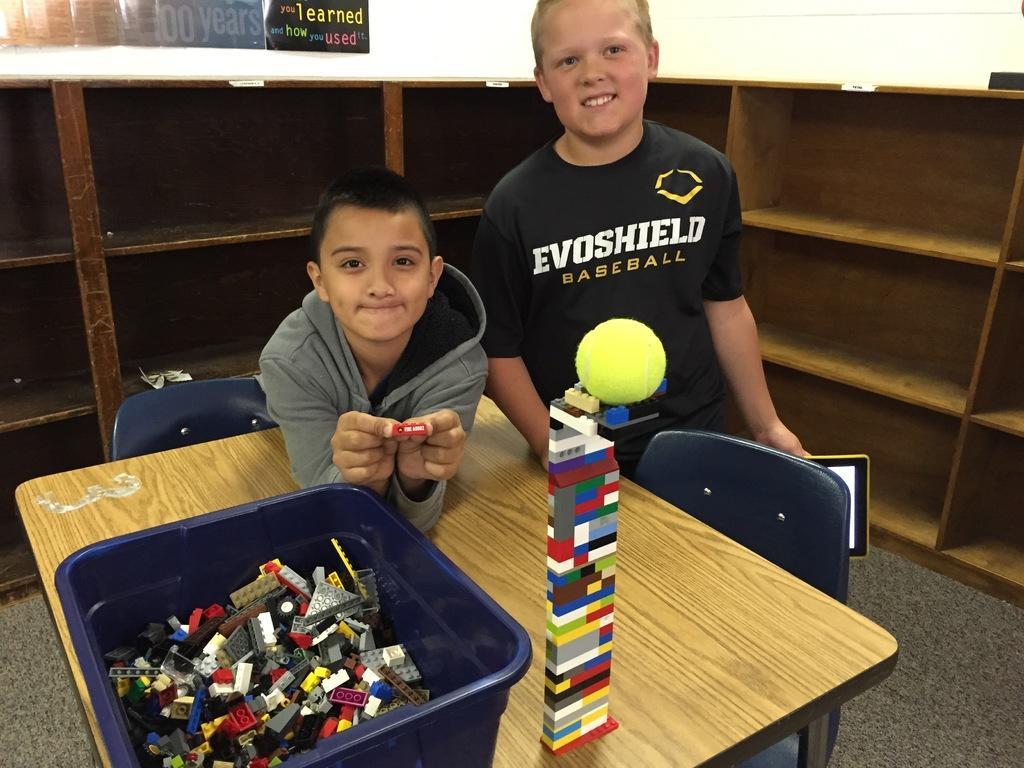In one or two sentences, can you explain what this image depicts? In this picture there are two boys. A boy with grey jacket is bending on the table and beside him there is another boy with black t-shirt is standing and he is smiling. In front of them there is a table with blue tub on it. In the tub there are some toys. Behind them there is a cupboard. At the back of cupboard there is a wall with posters on it. 